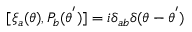Convert formula to latex. <formula><loc_0><loc_0><loc_500><loc_500>[ { \xi } _ { a } ( \theta ) , P _ { b } ( { \theta } ^ { ^ { \prime } } ) ] = i { \delta } _ { a b } { \delta } ( \theta - { \theta } ^ { ^ { \prime } } )</formula> 